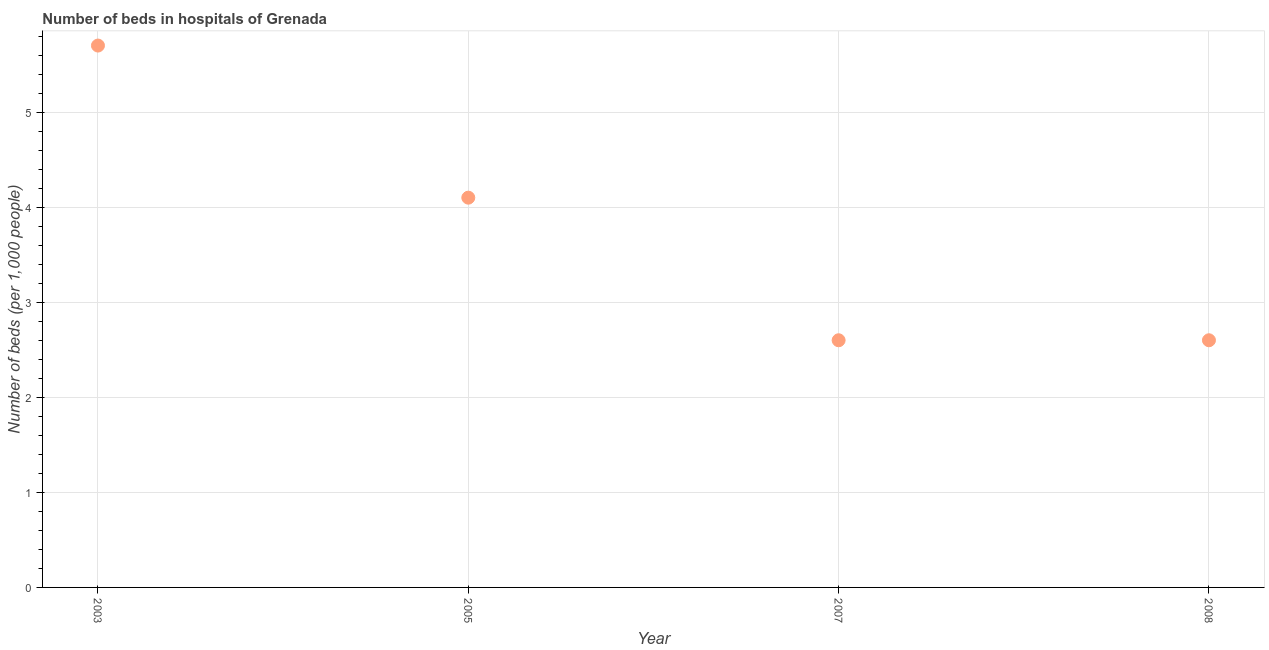What is the number of hospital beds in 2003?
Ensure brevity in your answer.  5.7. Across all years, what is the maximum number of hospital beds?
Your response must be concise. 5.7. Across all years, what is the minimum number of hospital beds?
Provide a short and direct response. 2.6. What is the sum of the number of hospital beds?
Your answer should be compact. 15. What is the difference between the number of hospital beds in 2005 and 2008?
Provide a succinct answer. 1.5. What is the average number of hospital beds per year?
Your answer should be compact. 3.75. What is the median number of hospital beds?
Offer a very short reply. 3.35. In how many years, is the number of hospital beds greater than 4 %?
Provide a succinct answer. 2. What is the ratio of the number of hospital beds in 2003 to that in 2007?
Make the answer very short. 2.19. What is the difference between the highest and the second highest number of hospital beds?
Give a very brief answer. 1.6. What is the difference between the highest and the lowest number of hospital beds?
Your response must be concise. 3.1. In how many years, is the number of hospital beds greater than the average number of hospital beds taken over all years?
Offer a terse response. 2. How many dotlines are there?
Ensure brevity in your answer.  1. How many years are there in the graph?
Your response must be concise. 4. What is the difference between two consecutive major ticks on the Y-axis?
Provide a succinct answer. 1. Does the graph contain any zero values?
Your answer should be very brief. No. Does the graph contain grids?
Your answer should be compact. Yes. What is the title of the graph?
Offer a very short reply. Number of beds in hospitals of Grenada. What is the label or title of the Y-axis?
Offer a terse response. Number of beds (per 1,0 people). What is the Number of beds (per 1,000 people) in 2003?
Offer a terse response. 5.7. What is the Number of beds (per 1,000 people) in 2007?
Your answer should be very brief. 2.6. What is the difference between the Number of beds (per 1,000 people) in 2003 and 2007?
Offer a terse response. 3.1. What is the difference between the Number of beds (per 1,000 people) in 2003 and 2008?
Make the answer very short. 3.1. What is the ratio of the Number of beds (per 1,000 people) in 2003 to that in 2005?
Give a very brief answer. 1.39. What is the ratio of the Number of beds (per 1,000 people) in 2003 to that in 2007?
Provide a short and direct response. 2.19. What is the ratio of the Number of beds (per 1,000 people) in 2003 to that in 2008?
Your response must be concise. 2.19. What is the ratio of the Number of beds (per 1,000 people) in 2005 to that in 2007?
Provide a short and direct response. 1.58. What is the ratio of the Number of beds (per 1,000 people) in 2005 to that in 2008?
Your response must be concise. 1.58. What is the ratio of the Number of beds (per 1,000 people) in 2007 to that in 2008?
Your answer should be very brief. 1. 